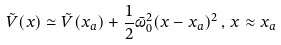<formula> <loc_0><loc_0><loc_500><loc_500>\tilde { V } ( x ) \simeq \tilde { V } ( x _ { a } ) + \frac { 1 } { 2 } \bar { \omega } _ { 0 } ^ { 2 } ( x - x _ { a } ) ^ { 2 } \, , \, x \approx x _ { a }</formula> 